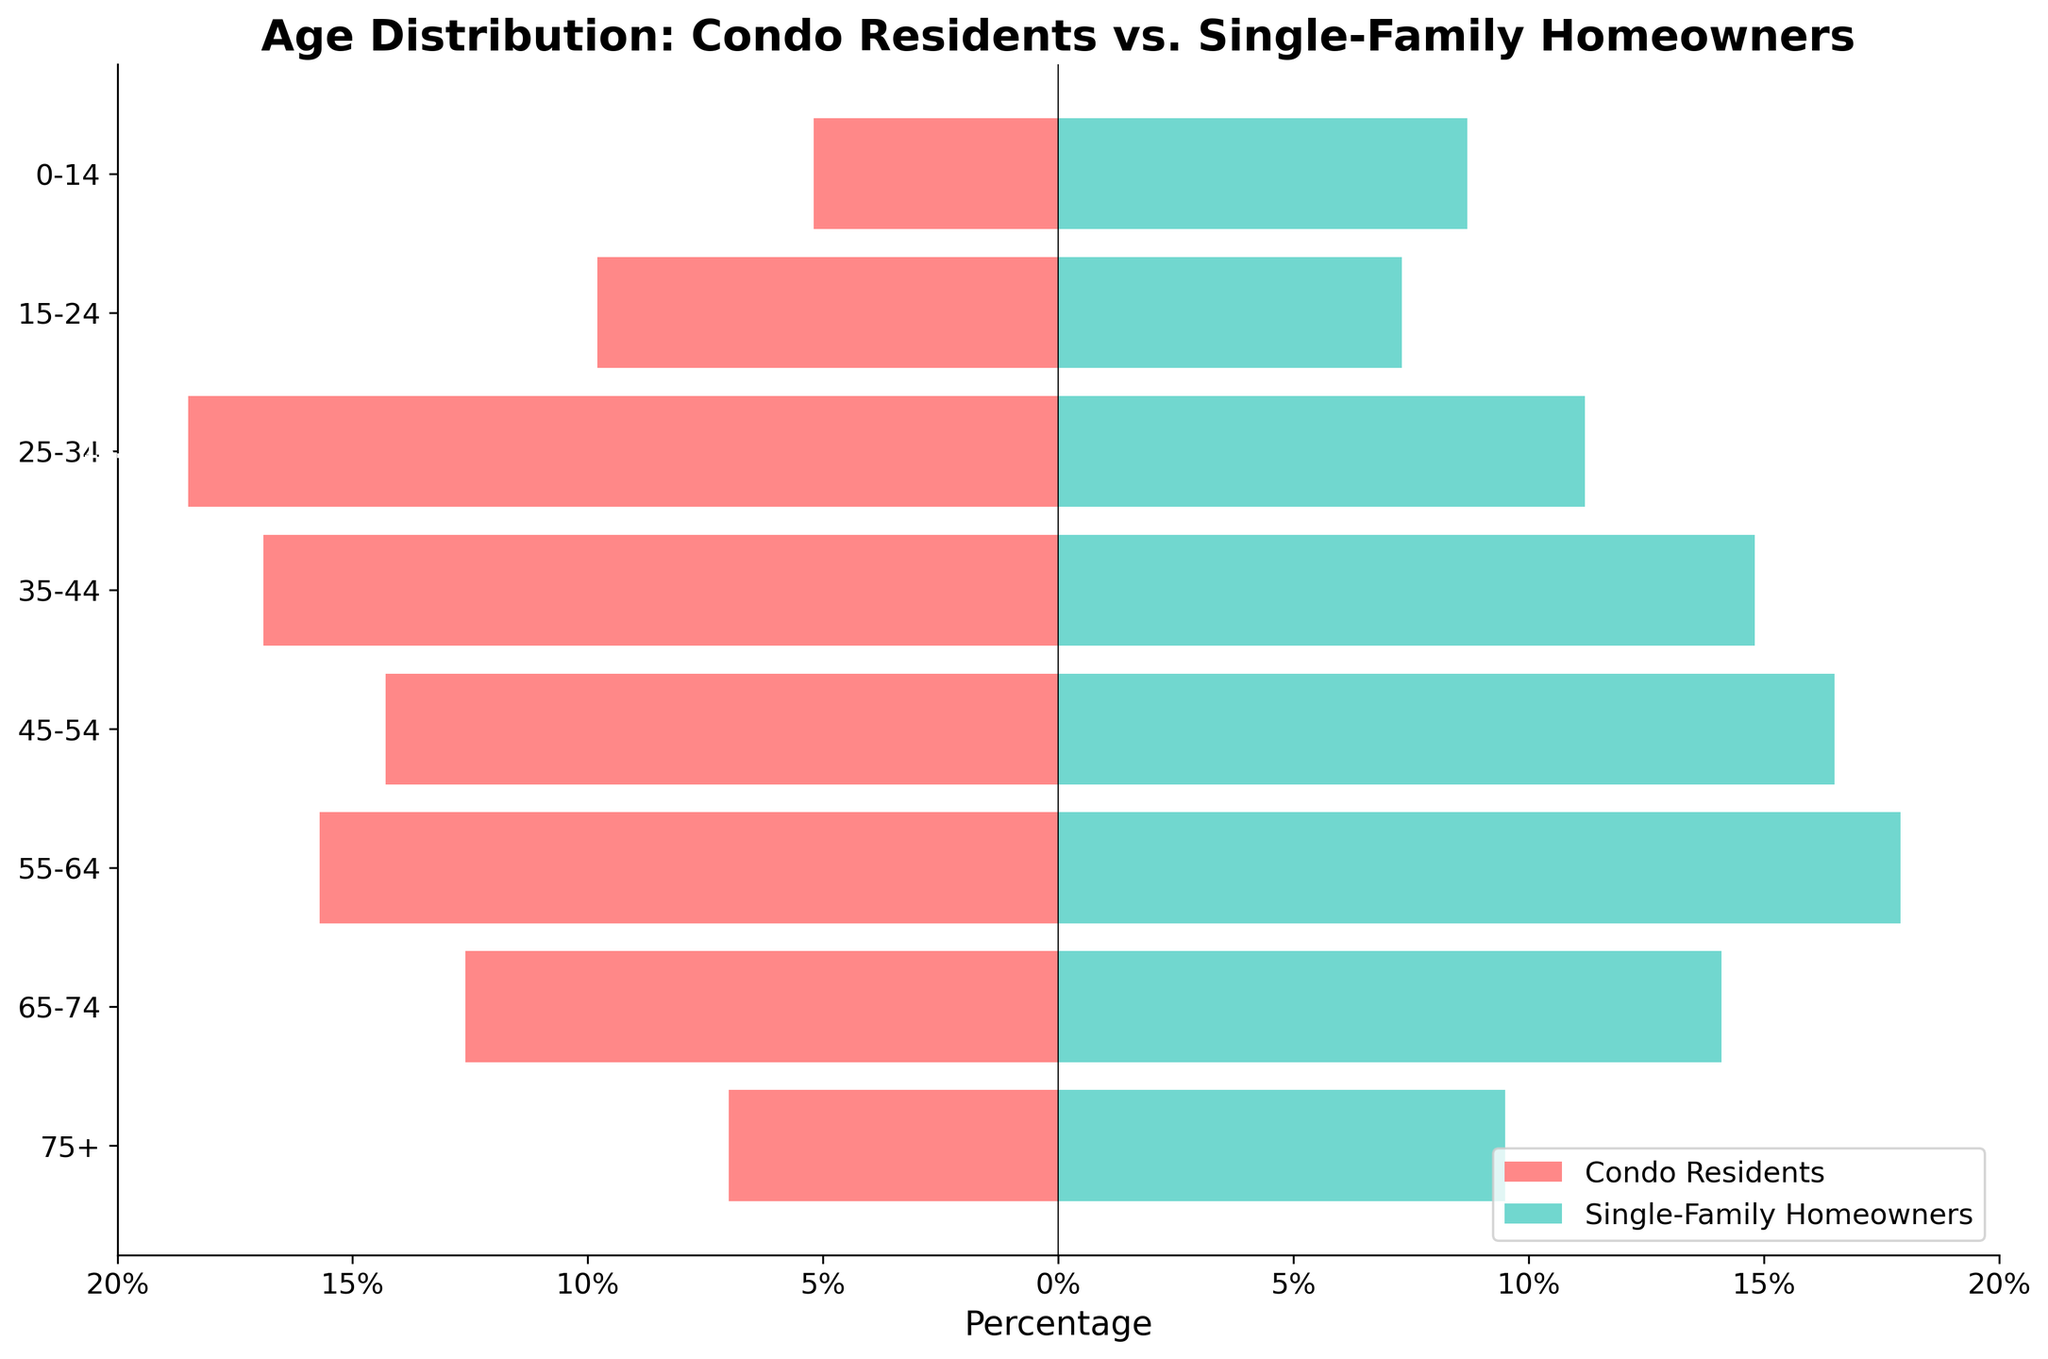What is the title of the figure? The title is usually placed at the top of the figure. This figure's title is clearly given as "Age Distribution: Condo Residents vs. Single-Family Homeowners."
Answer: Age Distribution: Condo Residents vs. Single-Family Homeowners What are the two groups being compared in the figure? The legend in the bottom right-hand corner indicates the two groups being compared: "Condo Residents" and "Single-Family Homeowners."
Answer: Condo Residents and Single-Family Homeowners How is the age group 25-34 depicted for condo residents versus homeowners? The horizontal bars for the age group 25-34 show that condo residents have an 18.5% representation, while single-family homeowners have an 11.2% representation.
Answer: 18.5% for condo residents, 11.2% for homeowners Which age group has the highest percentage of single-family homeowners? The bar corresponding to the highest value among single-family homeowners is the age group 55-64, with a percentage of 17.9%.
Answer: 55-64 How do the percentages of condo residents and single-family homeowners compare for the age group 75+? The bar for condo residents in the age group 75+ shows a percentage of 7.0%, while the bar for single-family homeowners shows a percentage of 9.5%.
Answer: 7.0% for condo residents, 9.5% for homeowners What is the total percentage representation of single-family homeowners between the ages 25-54? The percentages for single-family homeowners between 25-34, 35-44, and 45-54 are 11.2%, 14.8%, and 16.5%, respectively. Summing them up calculates the total representation: 11.2 + 14.8 + 16.5 = 42.5%.
Answer: 42.5% In which age group do condo residents significantly outnumber single-family homeowners? By comparing the lengths of the bars, the age group 25-34 has a significantly higher percentage of condo residents (18.5%) compared to single-family homeowners (11.2%).
Answer: 25-34 What is the percentage difference of condo residents and single-family homeowners in the age group 0-14? For condo residents, the percentage is -5.2%, and for single-family homeowners, it is 8.7%. The difference is calculated as 8.7% - (-5.2%) = 13.9%.
Answer: 13.9% Which age group has the smallest percentage of condo residents? The smallest percentage for condo residents is found in the age group 0-14, which shows -5.2% on the horizontal bar plot.
Answer: 0-14 What is the sum of the percentages for condo residents in the age groups 55-64 and 65-74? For the condo residents, the percentages for the age groups 55-64 and 65-74 are -15.7% and -12.6%, respectively. Adding them yields a sum: -15.7% + (-12.6%) = -28.3%.
Answer: -28.3% 